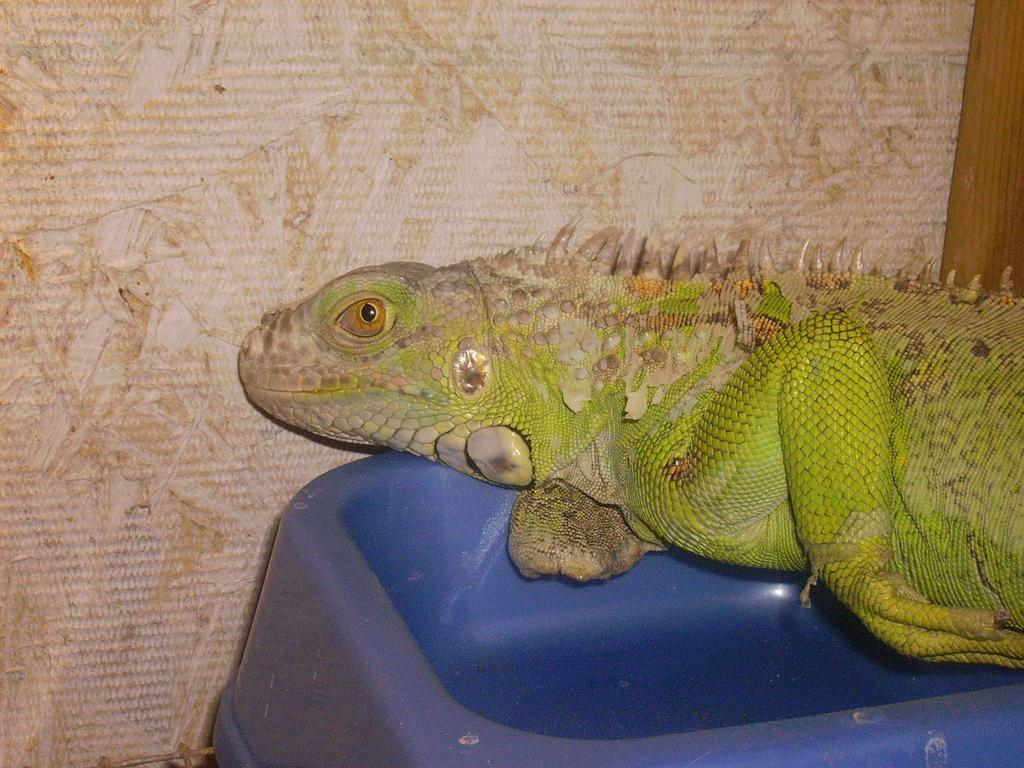What type of animal is in the image? There is a reptile in the image. What is the reptile resting on or interacting with? The reptile is on an object. What can be seen in the background of the image? There is a wall in the background of the image. What color is the aunt's feet in the image? There is no mention of an aunt or feet in the image, so we cannot answer that question. 